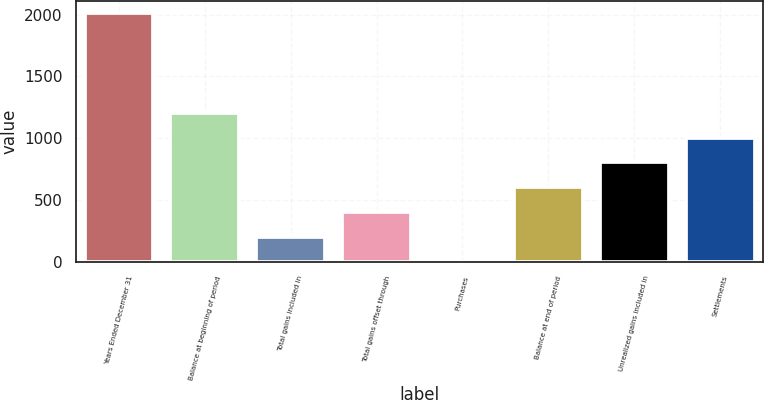Convert chart to OTSL. <chart><loc_0><loc_0><loc_500><loc_500><bar_chart><fcel>Years Ended December 31<fcel>Balance at beginning of period<fcel>Total gains included in<fcel>Total gains offset through<fcel>Purchases<fcel>Balance at end of period<fcel>Unrealized gains included in<fcel>Settlements<nl><fcel>2011<fcel>1207<fcel>202<fcel>403<fcel>1<fcel>604<fcel>805<fcel>1006<nl></chart> 